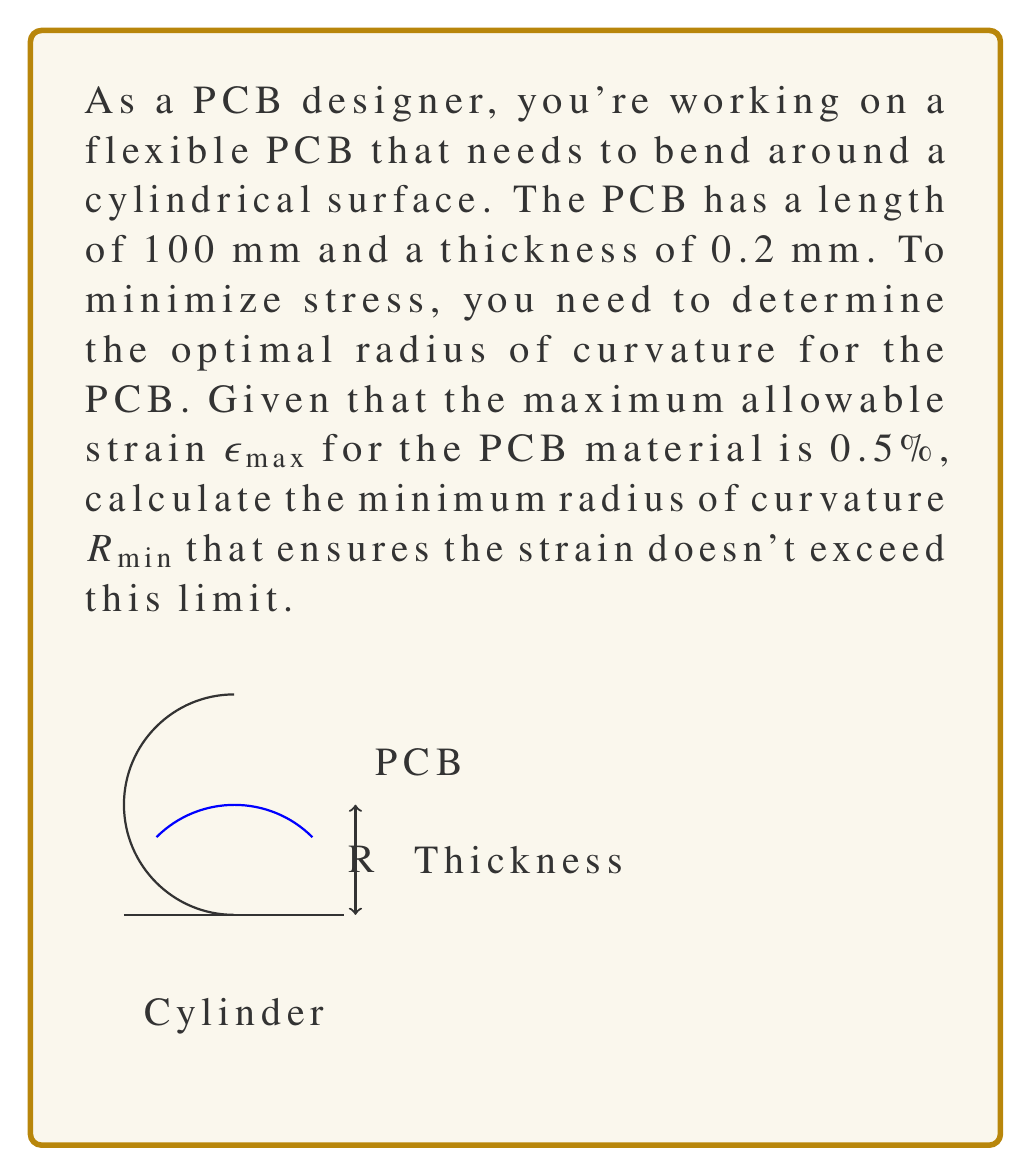Help me with this question. Let's approach this step-by-step:

1) The relationship between strain $\epsilon$, thickness $t$, and radius of curvature $R$ for a bent PCB is given by:

   $$\epsilon = \frac{t}{2R}$$

2) We're looking for the minimum radius, which occurs at the maximum allowable strain. So we can substitute $\epsilon_{max}$ for $\epsilon$:

   $$\epsilon_{max} = \frac{t}{2R_{min}}$$

3) We're given:
   - $\epsilon_{max} = 0.5\% = 0.005$
   - $t = 0.2$ mm

4) Let's substitute these values into our equation:

   $$0.005 = \frac{0.2}{2R_{min}}$$

5) Now, let's solve for $R_{min}$:

   $$R_{min} = \frac{0.2}{2(0.005)} = \frac{0.2}{0.01} = 20$$

6) Therefore, the minimum radius of curvature is 20 mm.

7) To verify, we can calculate the strain at this radius:

   $$\epsilon = \frac{t}{2R} = \frac{0.2}{2(20)} = 0.005 = 0.5\%$$

   This matches our maximum allowable strain, confirming our calculation.
Answer: $R_{min} = 20$ mm 